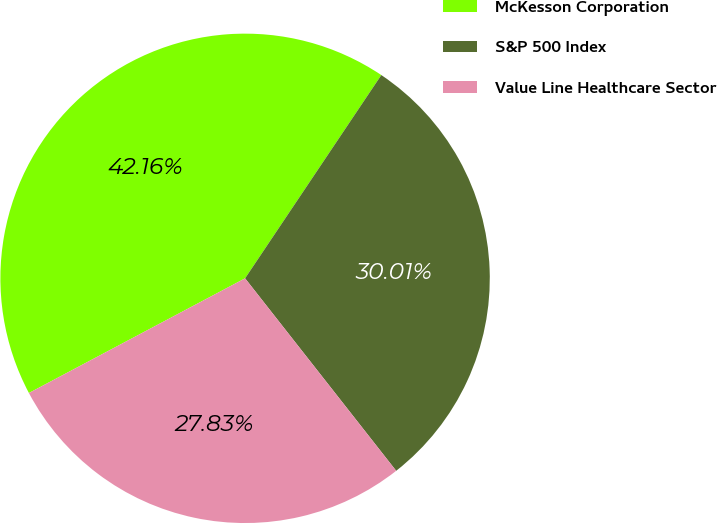Convert chart. <chart><loc_0><loc_0><loc_500><loc_500><pie_chart><fcel>McKesson Corporation<fcel>S&P 500 Index<fcel>Value Line Healthcare Sector<nl><fcel>42.16%<fcel>30.01%<fcel>27.83%<nl></chart> 